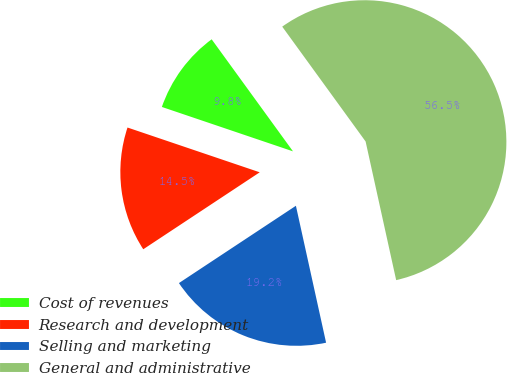<chart> <loc_0><loc_0><loc_500><loc_500><pie_chart><fcel>Cost of revenues<fcel>Research and development<fcel>Selling and marketing<fcel>General and administrative<nl><fcel>9.81%<fcel>14.49%<fcel>19.16%<fcel>56.54%<nl></chart> 